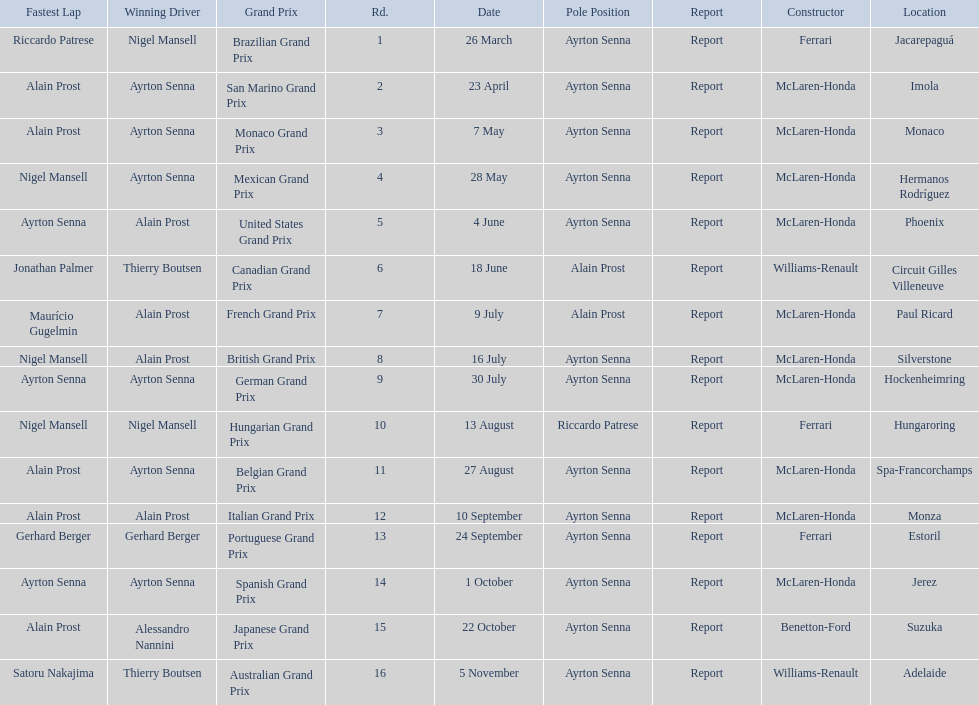Who won the spanish grand prix? McLaren-Honda. Who won the italian grand prix? McLaren-Honda. What grand prix did benneton-ford win? Japanese Grand Prix. 